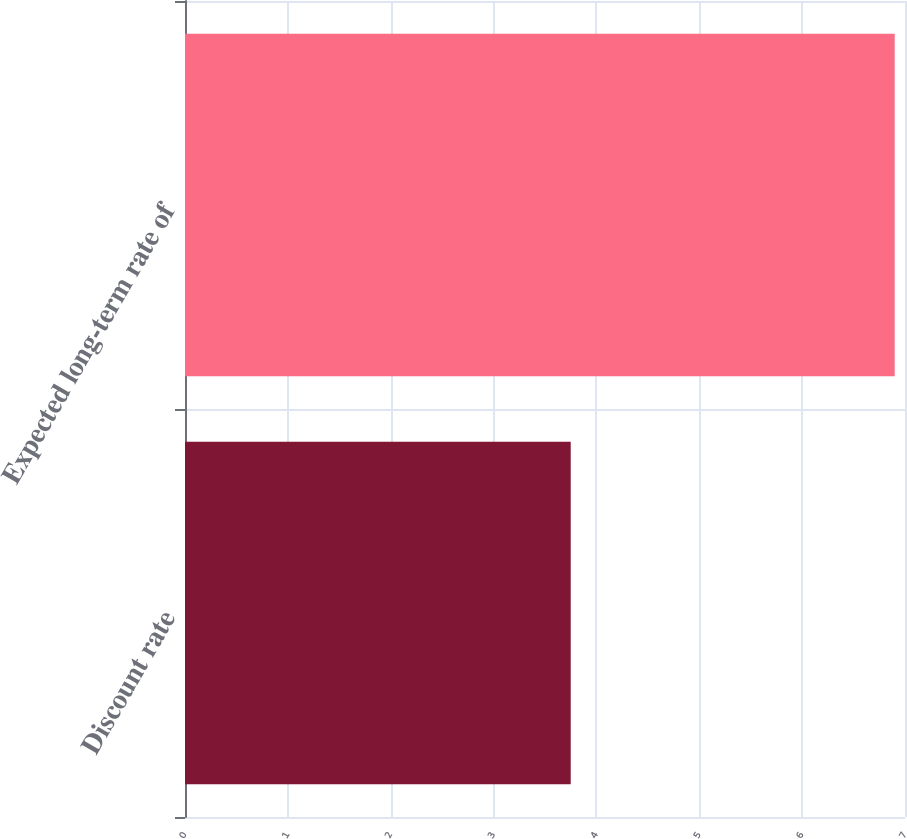<chart> <loc_0><loc_0><loc_500><loc_500><bar_chart><fcel>Discount rate<fcel>Expected long-term rate of<nl><fcel>3.75<fcel>6.9<nl></chart> 